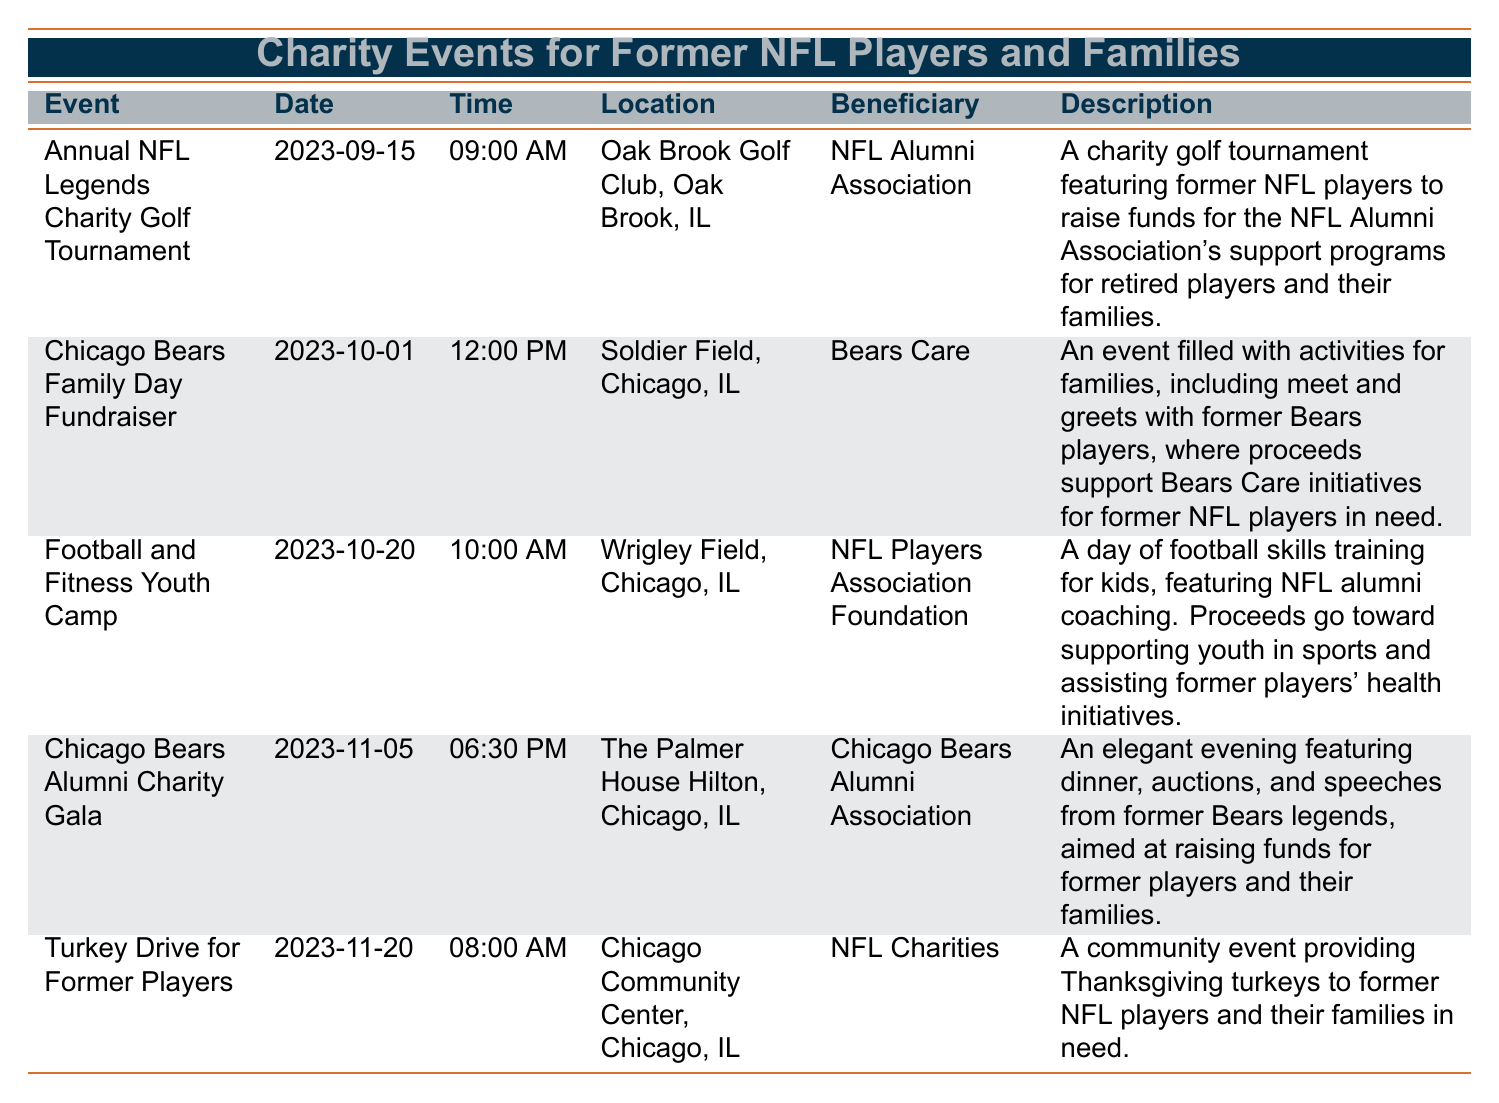What is the date of the Annual NFL Legends Charity Golf Tournament? The table lists the events with their respective dates. The Annual NFL Legends Charity Golf Tournament is scheduled for 2023-09-15.
Answer: 2023-09-15 Which event takes place first in October? In the table, there are two events listed for October: the Chicago Bears Family Day Fundraiser on October 1 and the Football and Fitness Youth Camp on October 20. The Chicago Bears Family Day Fundraiser is earlier in October.
Answer: Chicago Bears Family Day Fundraiser Is the beneficiary for the Turkey Drive for Former Players NFL Charities? The table shows that the beneficiary of the Turkey Drive for Former Players is NFL Charities. Therefore, the statement is true.
Answer: Yes How many charity events are scheduled in November? The table lists two events in November: the Chicago Bears Alumni Charity Gala on November 5 and the Turkey Drive for Former Players on November 20. Therefore, there are two events in November.
Answer: 2 What is the time of the Chicago Bears Alumni Charity Gala? Referring to the table, the Chicago Bears Alumni Charity Gala is scheduled for 6:30 PM.
Answer: 06:30 PM Which event has the longest description and what is that event? By examining the descriptions in the table, the Chicago Bears Alumni Charity Gala has the longest description related to an elegant evening with multiple activities aimed at raising funds.
Answer: Chicago Bears Alumni Charity Gala How many charity events benefit the NFL Alumni Association? The table indicates that there is one event specifically benefiting the NFL Alumni Association, which is the Annual NFL Legends Charity Golf Tournament.
Answer: 1 If you attend both the Chicago Bears Family Day Fundraiser and the Turkey Drive for Former Players, how many total hours will you spend at these events? The Chicago Bears Family Day Fundraiser starts at 12:00 PM and is a family-oriented event likely lasting several hours, but the exact duration isn't listed. The Turkey Drive for Former Players starts at 08:00 AM. Assuming the first event lasts about 4 hours, it would be from 12:00 PM to 04:00 PM, and the second event is also a morning event. However, without specific ending times, we can't calculate the exact total hours, but it's safe to say it would be at least 4 hours for the first event.
Answer: At least 4 hours What location hosts the Football and Fitness Youth Camp? According to the table, the Football and Fitness Youth Camp is hosted at Wrigley Field, Chicago, IL.
Answer: Wrigley Field, Chicago, IL 